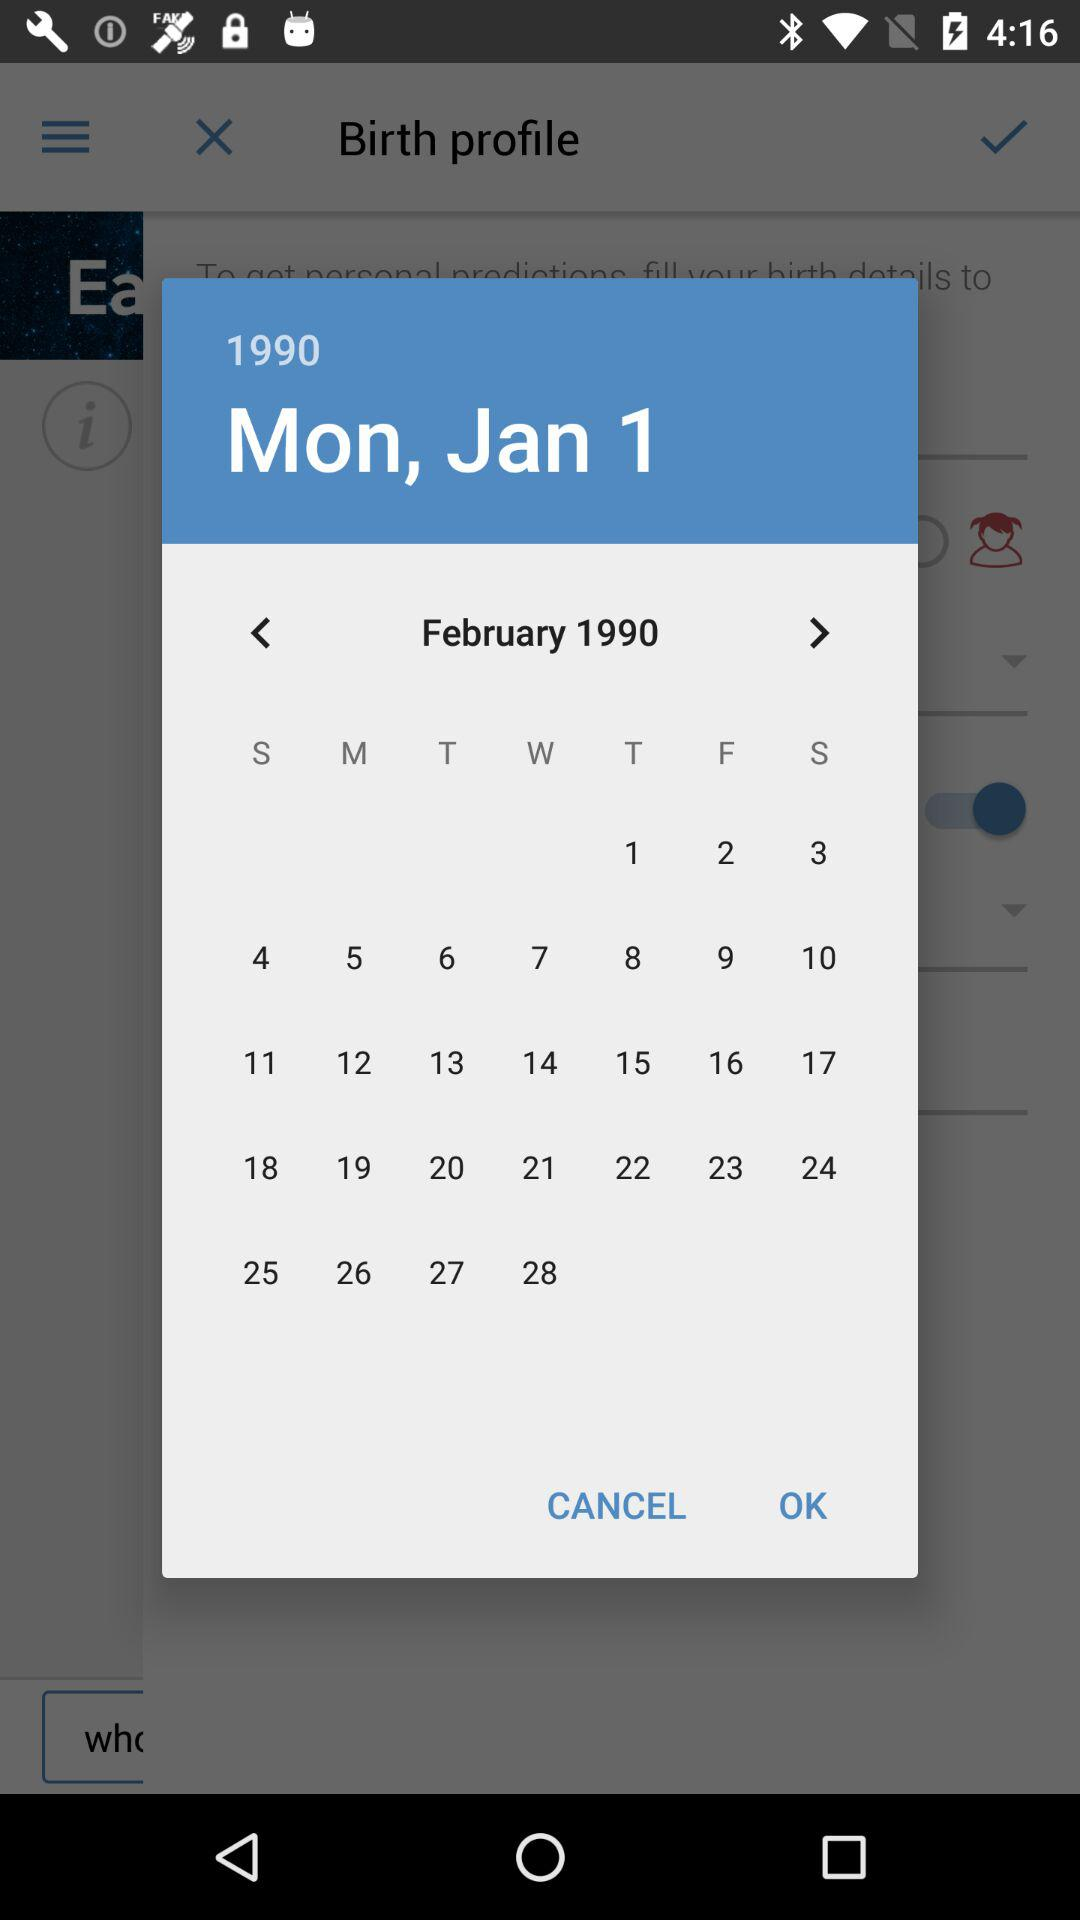What is the given year? The given year is 1990. 